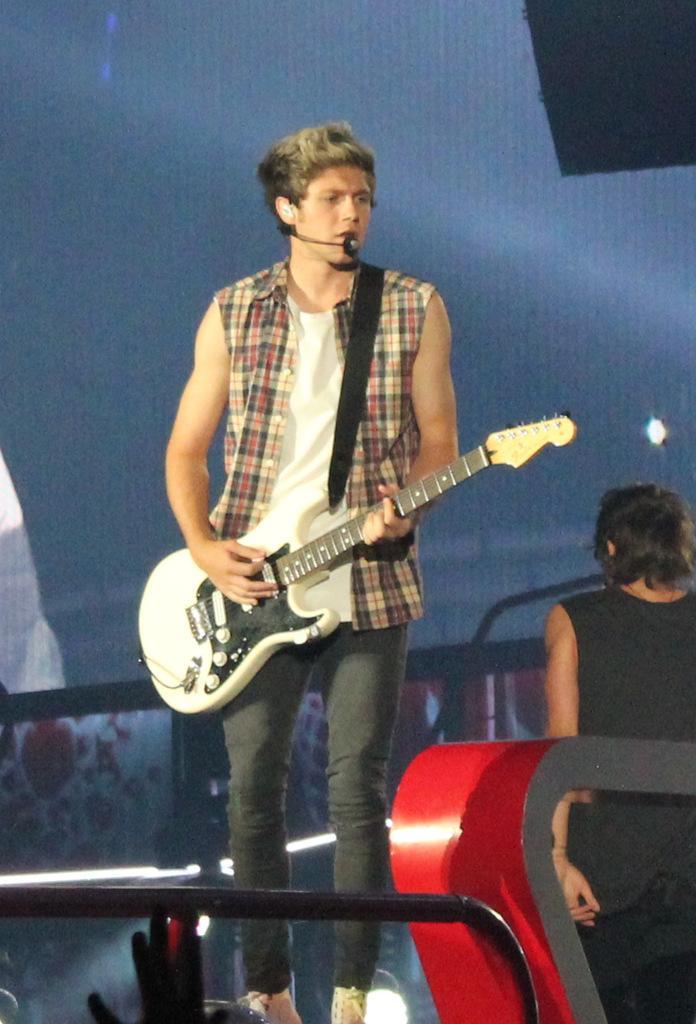How would you summarize this image in a sentence or two? There is a man standing, wearing a mic, singing, holding and playing guitar. I the background, there is a person standing, a light, and violet color wallpaper. In front of him, there is a red color material and some other objects. 